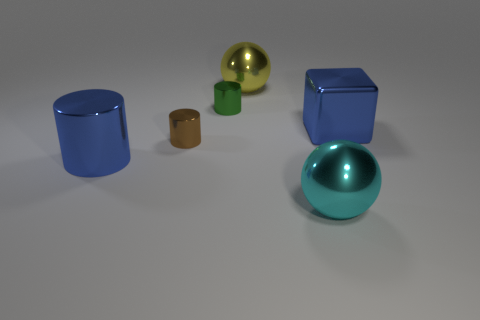There is a cylinder that is the same color as the big shiny block; what is it made of?
Give a very brief answer. Metal. How many balls are green objects or tiny brown metal things?
Your response must be concise. 0. How many large shiny objects are both in front of the yellow thing and behind the cyan sphere?
Keep it short and to the point. 2. Is the size of the green metal thing the same as the blue shiny thing that is to the left of the small green thing?
Your response must be concise. No. There is a cylinder behind the large blue thing that is behind the tiny brown object; is there a green shiny cylinder that is behind it?
Make the answer very short. No. There is a yellow object behind the small cylinder in front of the blue cube; what is it made of?
Your answer should be very brief. Metal. There is a object that is both behind the brown object and in front of the green metal cylinder; what is its material?
Make the answer very short. Metal. Is there another metal thing that has the same shape as the green metal thing?
Provide a short and direct response. Yes. Are there any small brown shiny cylinders right of the small shiny object that is behind the large blue metallic block?
Your response must be concise. No. How many small objects are the same material as the big yellow sphere?
Give a very brief answer. 2. 